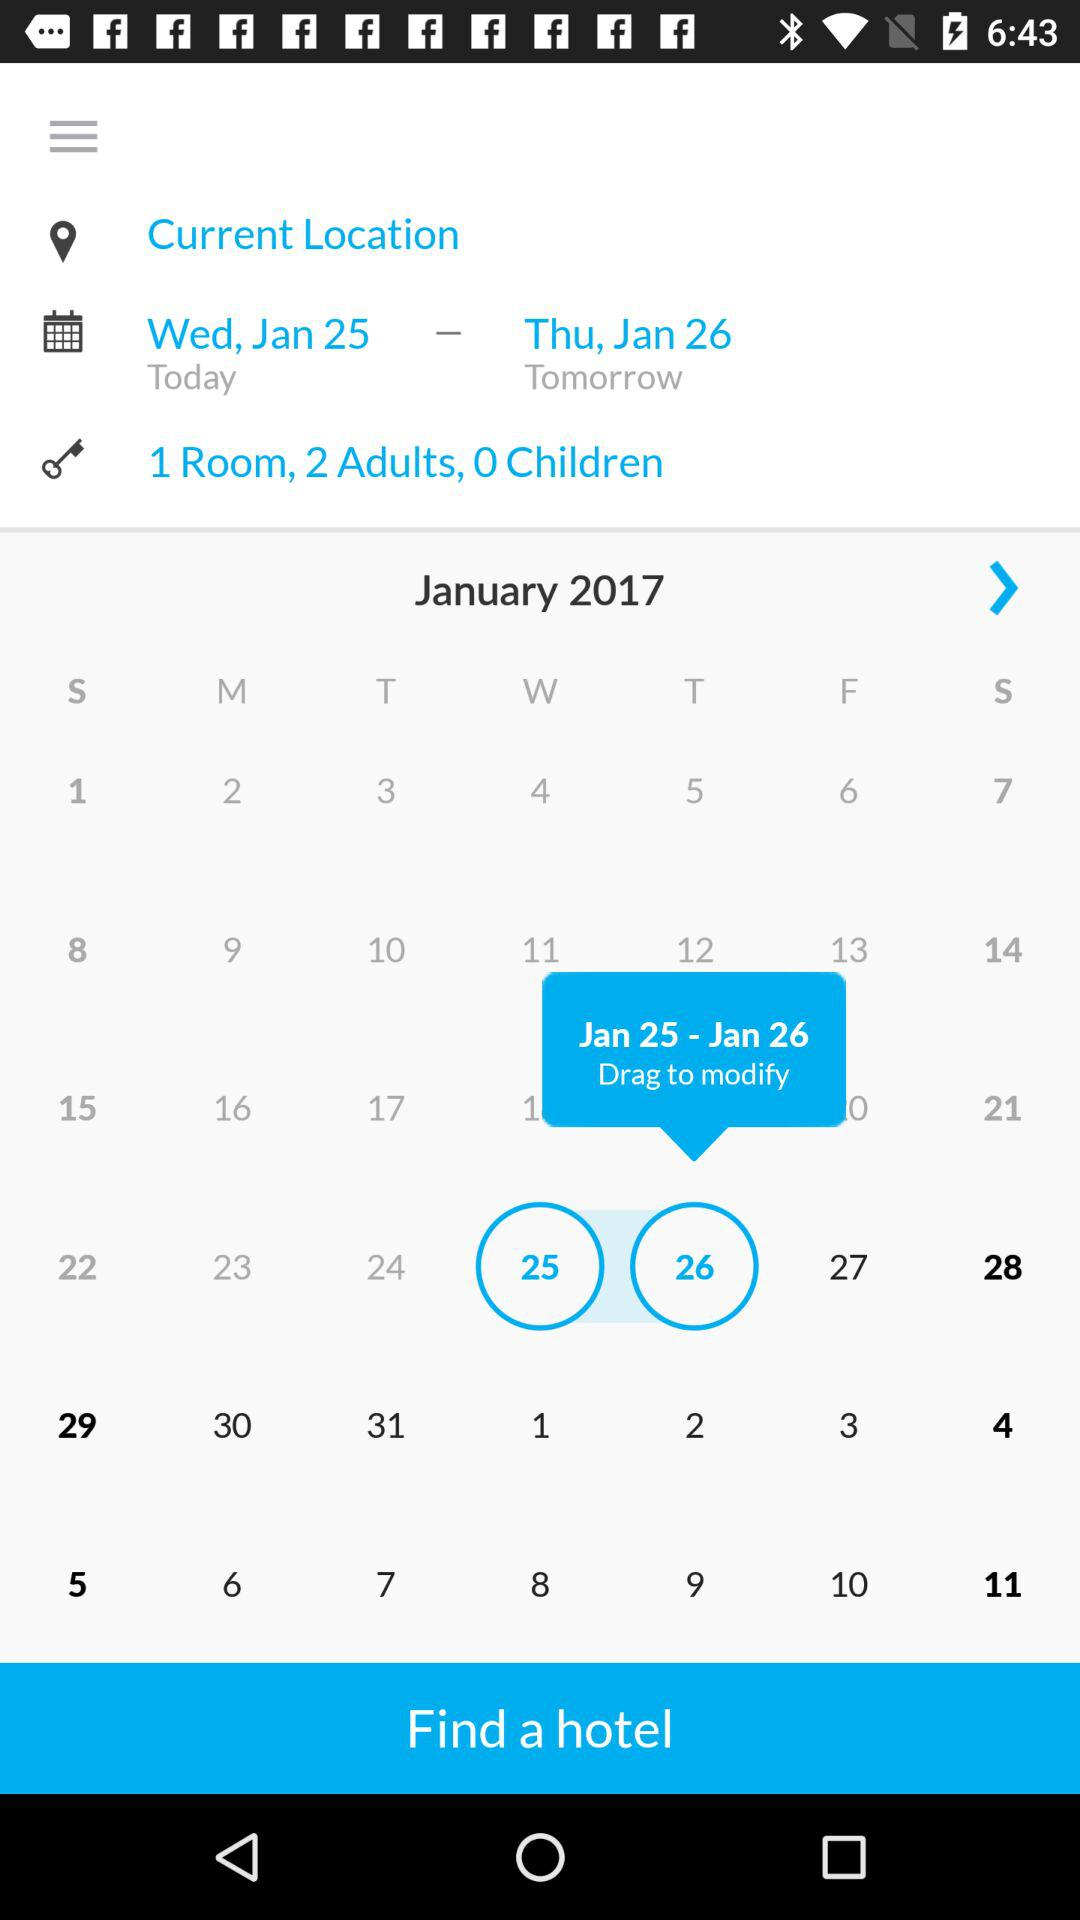Which date is selected from the calendar? The selected dates are Wednesday, January 25, 2017 and Thursday, January 26, 2017. 